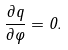<formula> <loc_0><loc_0><loc_500><loc_500>\frac { \partial q } { \partial \varphi } = 0 .</formula> 